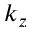<formula> <loc_0><loc_0><loc_500><loc_500>k _ { z }</formula> 